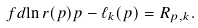Convert formula to latex. <formula><loc_0><loc_0><loc_500><loc_500>\ f d { \ln r ( p ) } p - \ell _ { k } ( p ) = R _ { p , k } .</formula> 